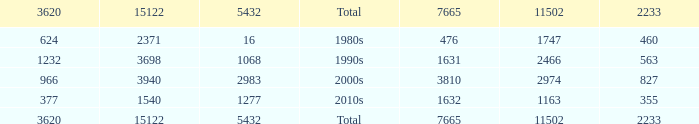What is the highest 3620 value with a 5432 of 5432 and a 15122 greater than 15122? None. 